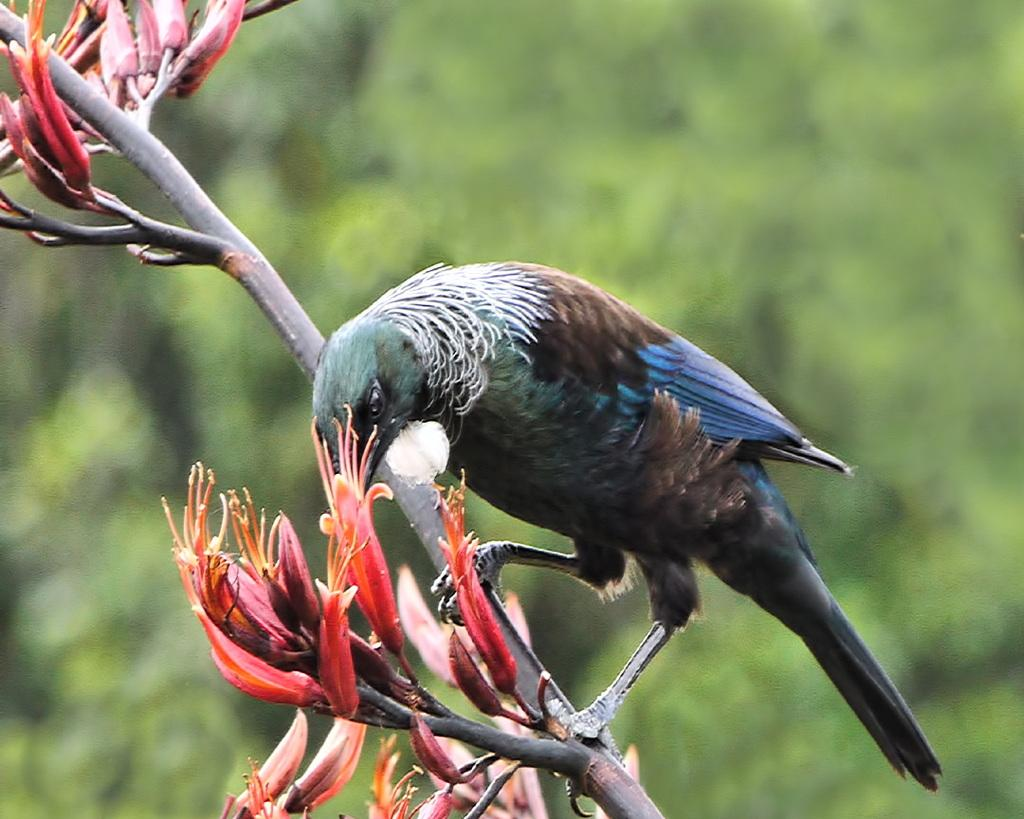What type of animal is present in the image? There is a bird in the image. Where is the bird located? The bird is on the stem of a plant. What else can be seen on the plant in the image? There are a few buds in the image. Can you describe the background of the image? The background of the image is blurry. How does the bird smash the car in the image? There is no car present in the image, so the bird cannot smash a car. 